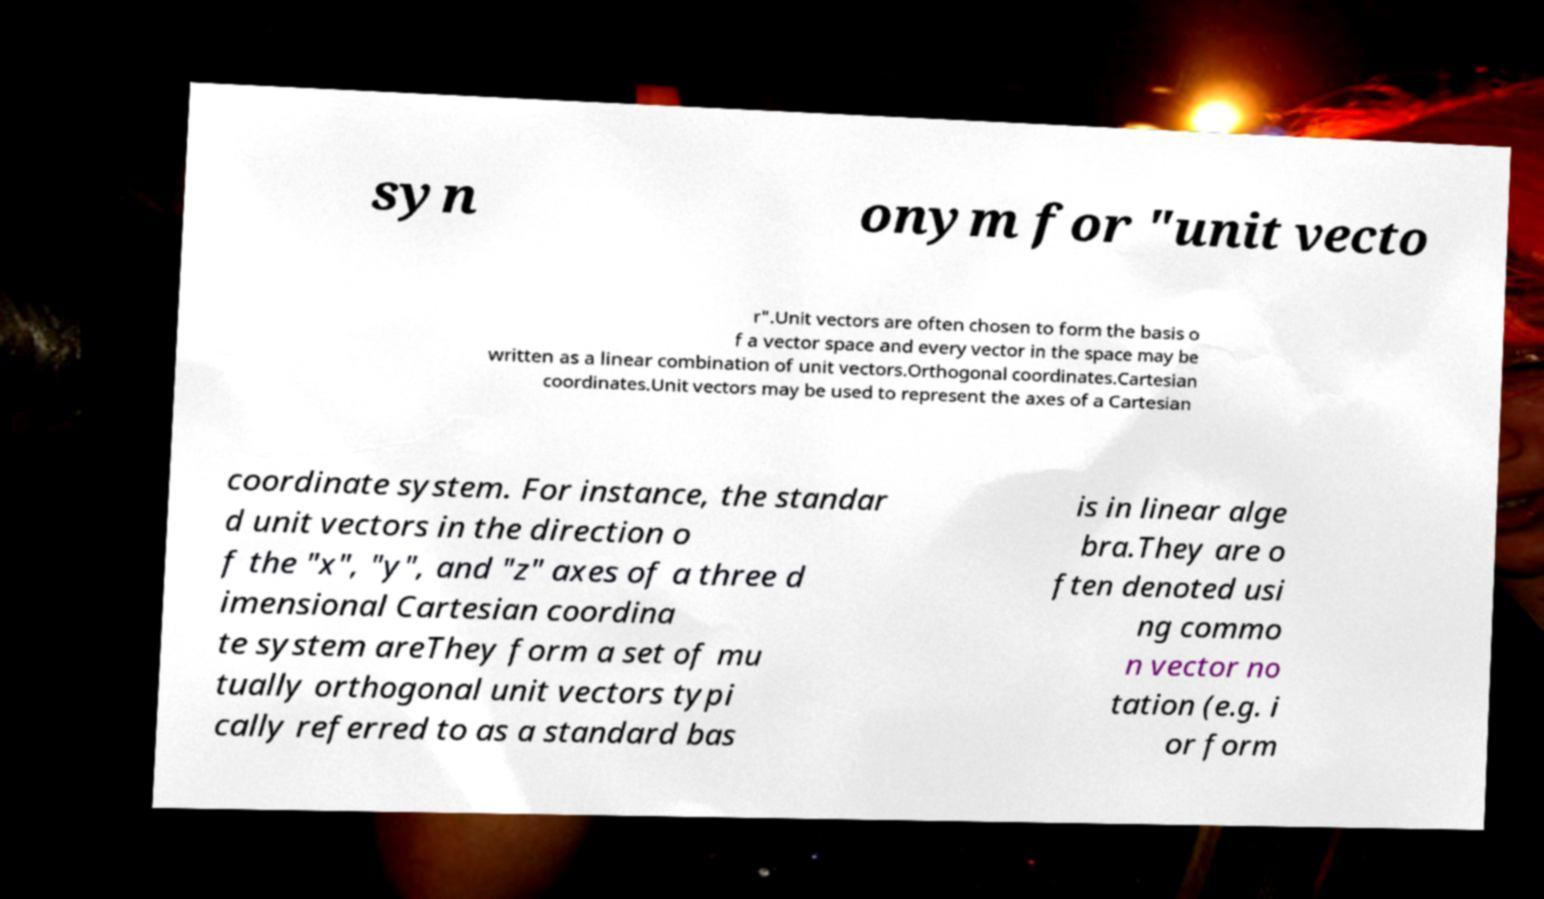Can you accurately transcribe the text from the provided image for me? syn onym for "unit vecto r".Unit vectors are often chosen to form the basis o f a vector space and every vector in the space may be written as a linear combination of unit vectors.Orthogonal coordinates.Cartesian coordinates.Unit vectors may be used to represent the axes of a Cartesian coordinate system. For instance, the standar d unit vectors in the direction o f the "x", "y", and "z" axes of a three d imensional Cartesian coordina te system areThey form a set of mu tually orthogonal unit vectors typi cally referred to as a standard bas is in linear alge bra.They are o ften denoted usi ng commo n vector no tation (e.g. i or form 